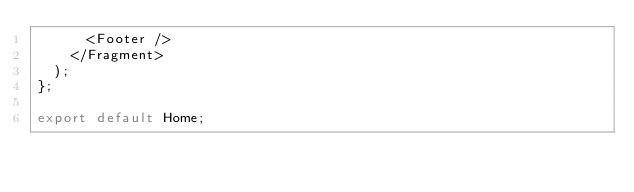Convert code to text. <code><loc_0><loc_0><loc_500><loc_500><_JavaScript_>      <Footer />
    </Fragment>
  );
};

export default Home;
</code> 